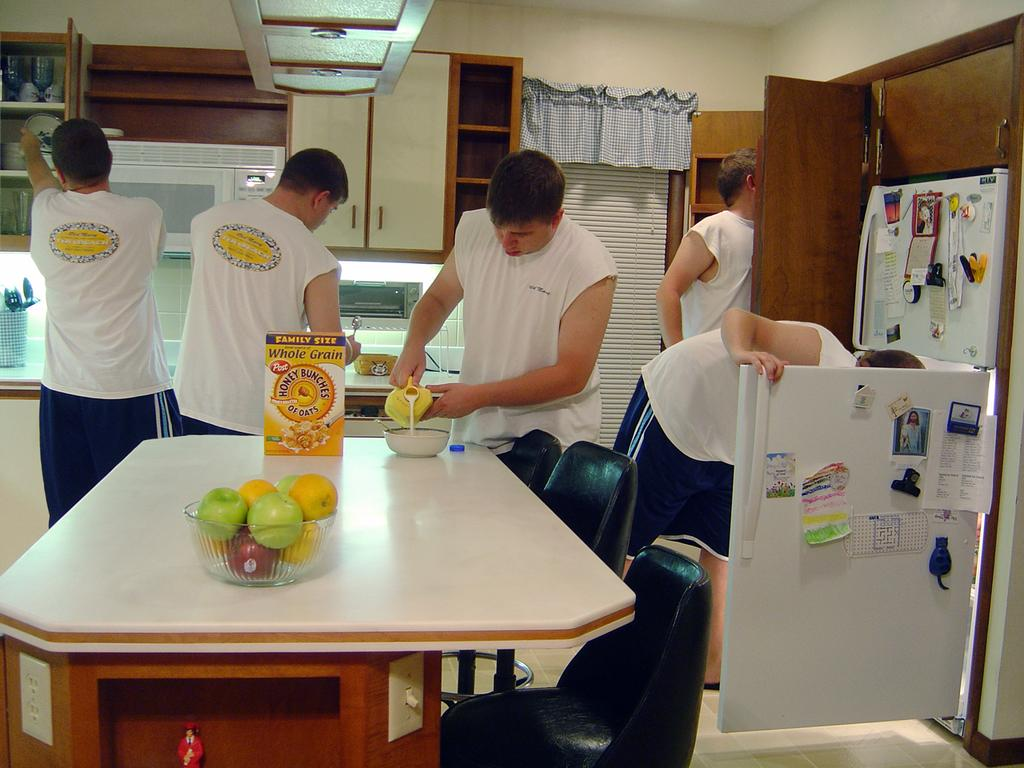<image>
Give a short and clear explanation of the subsequent image. Five men are in the kitchen working and one in the middle pours milk into the bowl next to the Whole Grain oats. 